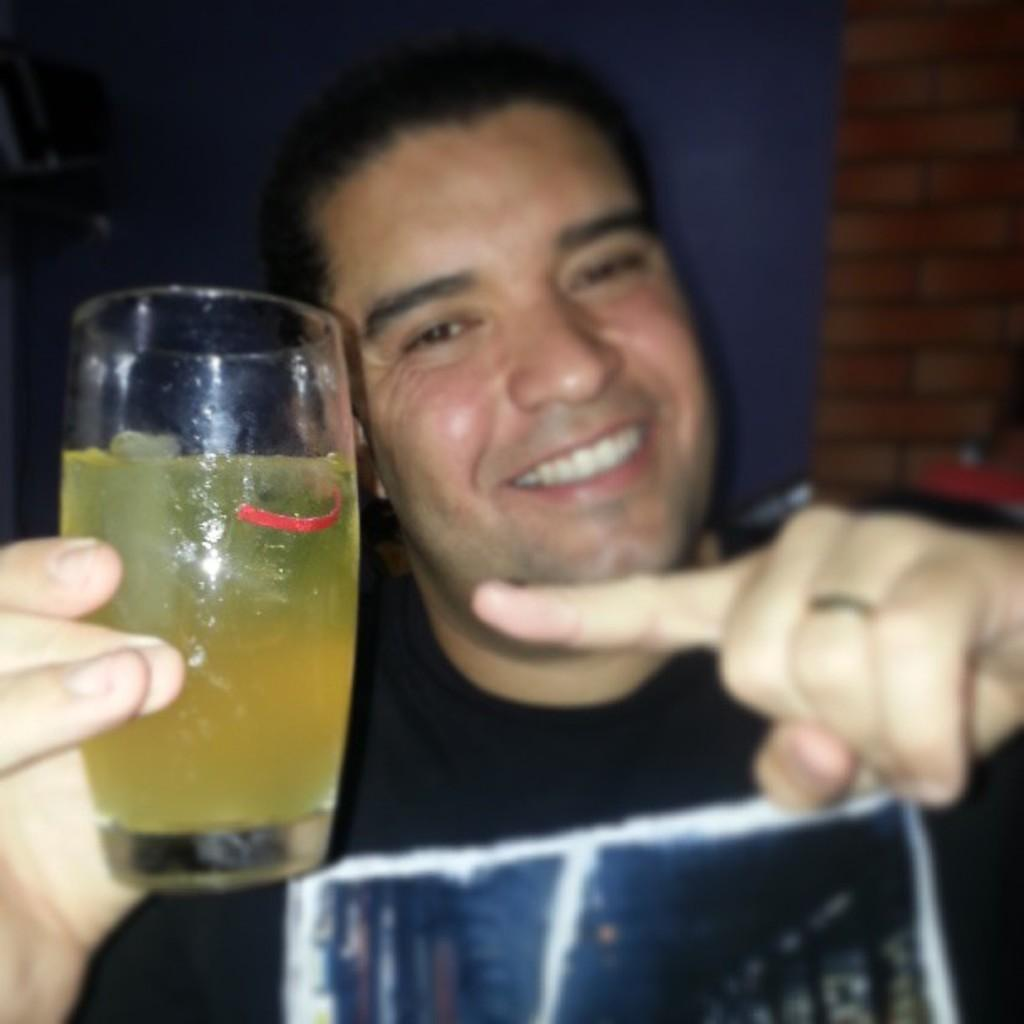Who or what is present in the image? There is a person in the image. What is the person doing in the image? The person is smiling. What object is the person holding in the image? The person is holding a glass. What type of trail can be seen behind the person in the image? There is no trail visible in the image; it only features a person holding a glass and smiling. 